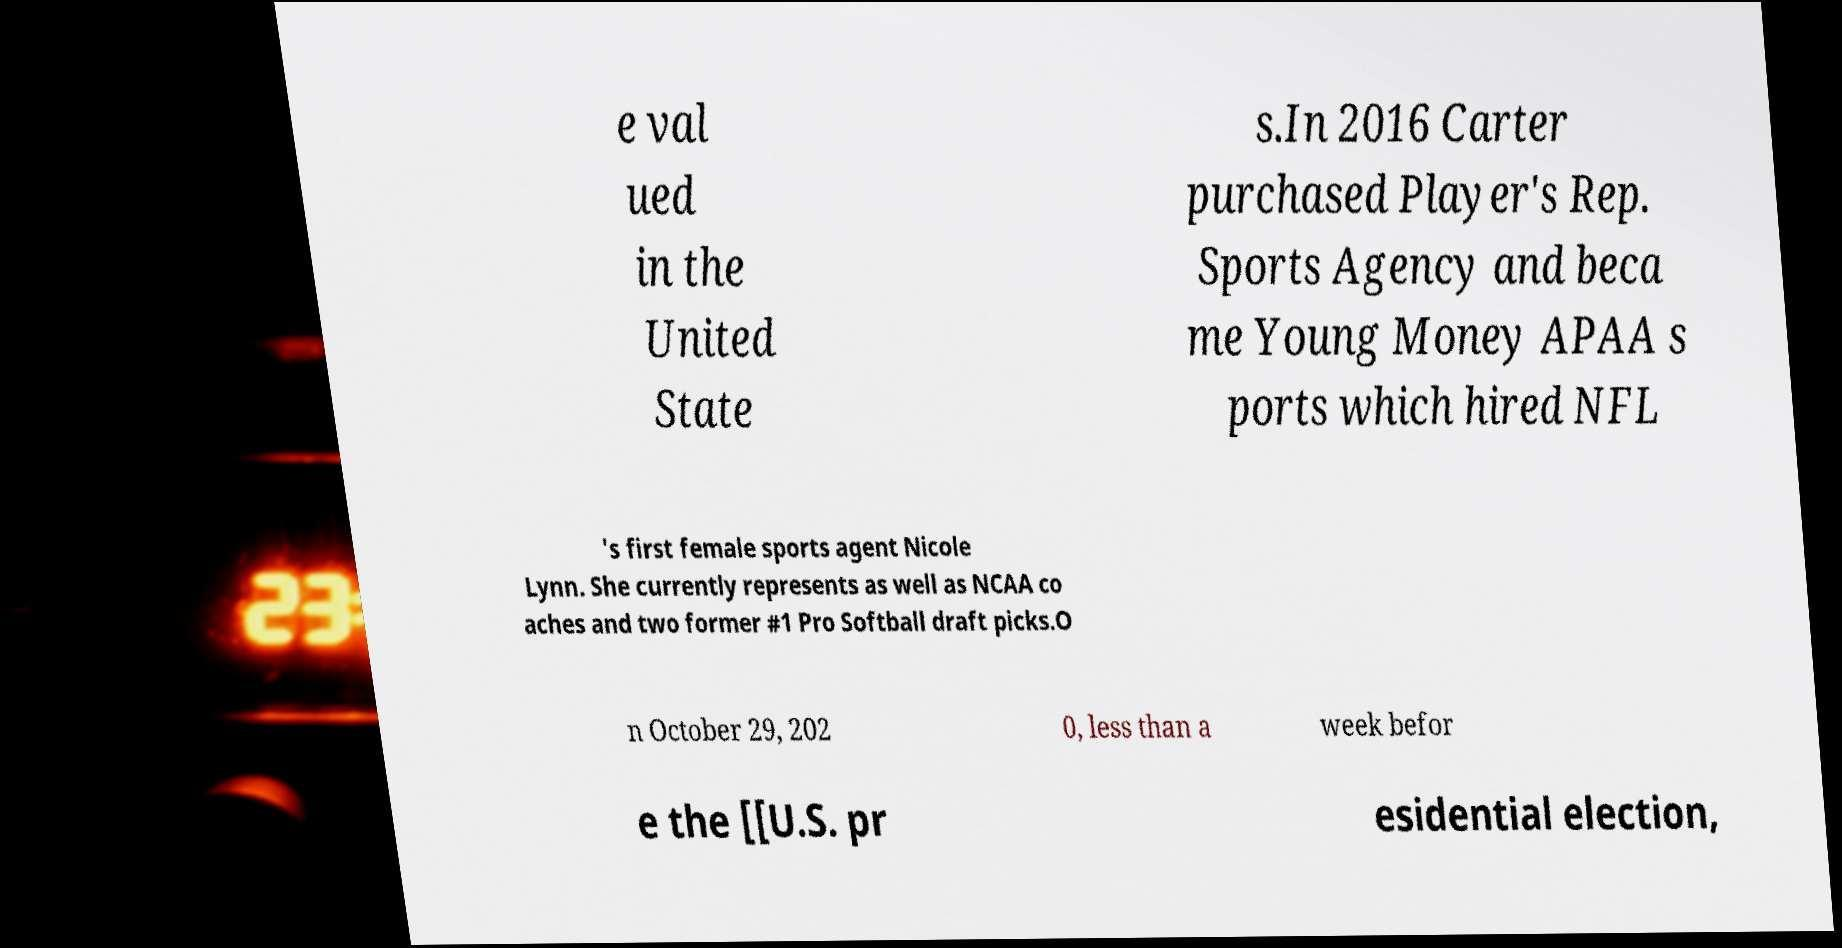Can you accurately transcribe the text from the provided image for me? e val ued in the United State s.In 2016 Carter purchased Player's Rep. Sports Agency and beca me Young Money APAA s ports which hired NFL 's first female sports agent Nicole Lynn. She currently represents as well as NCAA co aches and two former #1 Pro Softball draft picks.O n October 29, 202 0, less than a week befor e the [[U.S. pr esidential election, 